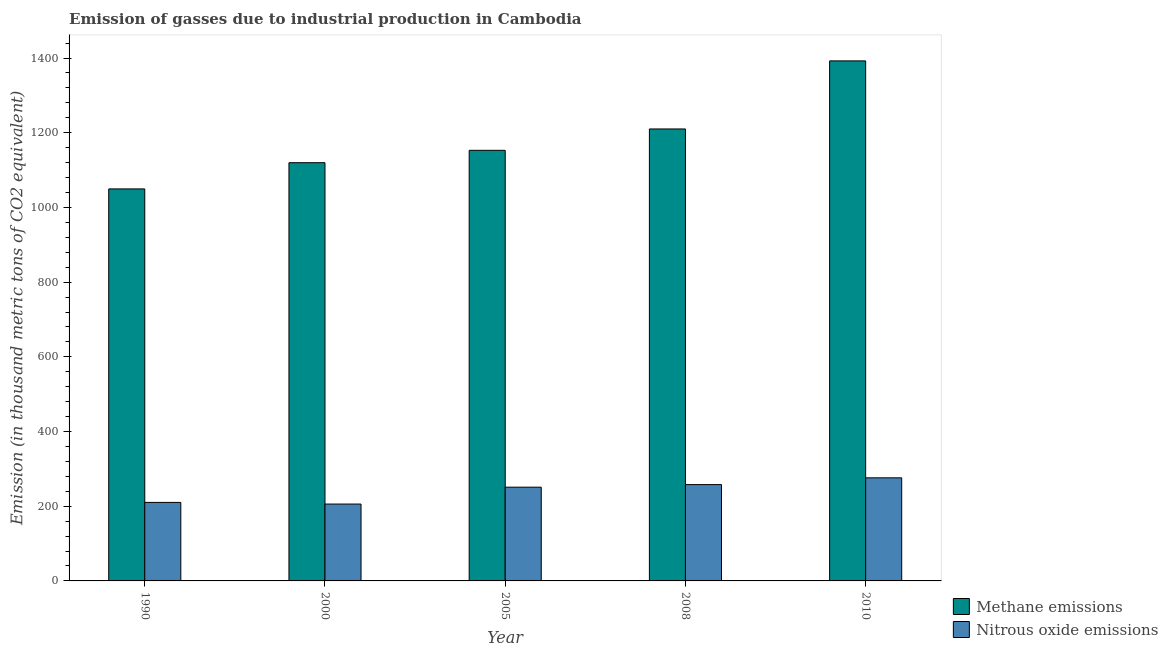Are the number of bars per tick equal to the number of legend labels?
Your response must be concise. Yes. How many bars are there on the 4th tick from the right?
Keep it short and to the point. 2. What is the amount of nitrous oxide emissions in 1990?
Give a very brief answer. 210.2. Across all years, what is the maximum amount of nitrous oxide emissions?
Provide a short and direct response. 276. Across all years, what is the minimum amount of nitrous oxide emissions?
Your answer should be very brief. 205.8. In which year was the amount of nitrous oxide emissions maximum?
Your answer should be compact. 2010. What is the total amount of nitrous oxide emissions in the graph?
Provide a short and direct response. 1200.9. What is the difference between the amount of nitrous oxide emissions in 2005 and that in 2010?
Your response must be concise. -25. What is the difference between the amount of methane emissions in 2000 and the amount of nitrous oxide emissions in 2008?
Offer a terse response. -90.3. What is the average amount of nitrous oxide emissions per year?
Offer a terse response. 240.18. What is the ratio of the amount of nitrous oxide emissions in 1990 to that in 2010?
Your answer should be compact. 0.76. What is the difference between the highest and the second highest amount of methane emissions?
Provide a succinct answer. 182.3. What is the difference between the highest and the lowest amount of methane emissions?
Provide a succinct answer. 342.8. Is the sum of the amount of nitrous oxide emissions in 2005 and 2010 greater than the maximum amount of methane emissions across all years?
Ensure brevity in your answer.  Yes. What does the 2nd bar from the left in 2010 represents?
Your response must be concise. Nitrous oxide emissions. What does the 1st bar from the right in 2005 represents?
Offer a very short reply. Nitrous oxide emissions. How many bars are there?
Your response must be concise. 10. Are all the bars in the graph horizontal?
Your answer should be compact. No. How many years are there in the graph?
Ensure brevity in your answer.  5. What is the difference between two consecutive major ticks on the Y-axis?
Make the answer very short. 200. Does the graph contain any zero values?
Provide a short and direct response. No. How many legend labels are there?
Your response must be concise. 2. What is the title of the graph?
Give a very brief answer. Emission of gasses due to industrial production in Cambodia. What is the label or title of the Y-axis?
Your answer should be compact. Emission (in thousand metric tons of CO2 equivalent). What is the Emission (in thousand metric tons of CO2 equivalent) of Methane emissions in 1990?
Your response must be concise. 1049.6. What is the Emission (in thousand metric tons of CO2 equivalent) of Nitrous oxide emissions in 1990?
Your response must be concise. 210.2. What is the Emission (in thousand metric tons of CO2 equivalent) of Methane emissions in 2000?
Make the answer very short. 1119.8. What is the Emission (in thousand metric tons of CO2 equivalent) in Nitrous oxide emissions in 2000?
Make the answer very short. 205.8. What is the Emission (in thousand metric tons of CO2 equivalent) of Methane emissions in 2005?
Offer a terse response. 1152.9. What is the Emission (in thousand metric tons of CO2 equivalent) in Nitrous oxide emissions in 2005?
Your response must be concise. 251. What is the Emission (in thousand metric tons of CO2 equivalent) of Methane emissions in 2008?
Offer a terse response. 1210.1. What is the Emission (in thousand metric tons of CO2 equivalent) of Nitrous oxide emissions in 2008?
Your response must be concise. 257.9. What is the Emission (in thousand metric tons of CO2 equivalent) in Methane emissions in 2010?
Ensure brevity in your answer.  1392.4. What is the Emission (in thousand metric tons of CO2 equivalent) of Nitrous oxide emissions in 2010?
Your answer should be compact. 276. Across all years, what is the maximum Emission (in thousand metric tons of CO2 equivalent) of Methane emissions?
Your answer should be compact. 1392.4. Across all years, what is the maximum Emission (in thousand metric tons of CO2 equivalent) in Nitrous oxide emissions?
Provide a short and direct response. 276. Across all years, what is the minimum Emission (in thousand metric tons of CO2 equivalent) in Methane emissions?
Ensure brevity in your answer.  1049.6. Across all years, what is the minimum Emission (in thousand metric tons of CO2 equivalent) in Nitrous oxide emissions?
Your answer should be very brief. 205.8. What is the total Emission (in thousand metric tons of CO2 equivalent) of Methane emissions in the graph?
Provide a short and direct response. 5924.8. What is the total Emission (in thousand metric tons of CO2 equivalent) of Nitrous oxide emissions in the graph?
Ensure brevity in your answer.  1200.9. What is the difference between the Emission (in thousand metric tons of CO2 equivalent) of Methane emissions in 1990 and that in 2000?
Provide a succinct answer. -70.2. What is the difference between the Emission (in thousand metric tons of CO2 equivalent) in Methane emissions in 1990 and that in 2005?
Your answer should be compact. -103.3. What is the difference between the Emission (in thousand metric tons of CO2 equivalent) of Nitrous oxide emissions in 1990 and that in 2005?
Offer a very short reply. -40.8. What is the difference between the Emission (in thousand metric tons of CO2 equivalent) in Methane emissions in 1990 and that in 2008?
Your answer should be compact. -160.5. What is the difference between the Emission (in thousand metric tons of CO2 equivalent) in Nitrous oxide emissions in 1990 and that in 2008?
Ensure brevity in your answer.  -47.7. What is the difference between the Emission (in thousand metric tons of CO2 equivalent) in Methane emissions in 1990 and that in 2010?
Provide a short and direct response. -342.8. What is the difference between the Emission (in thousand metric tons of CO2 equivalent) of Nitrous oxide emissions in 1990 and that in 2010?
Offer a terse response. -65.8. What is the difference between the Emission (in thousand metric tons of CO2 equivalent) of Methane emissions in 2000 and that in 2005?
Your answer should be very brief. -33.1. What is the difference between the Emission (in thousand metric tons of CO2 equivalent) of Nitrous oxide emissions in 2000 and that in 2005?
Ensure brevity in your answer.  -45.2. What is the difference between the Emission (in thousand metric tons of CO2 equivalent) of Methane emissions in 2000 and that in 2008?
Keep it short and to the point. -90.3. What is the difference between the Emission (in thousand metric tons of CO2 equivalent) in Nitrous oxide emissions in 2000 and that in 2008?
Make the answer very short. -52.1. What is the difference between the Emission (in thousand metric tons of CO2 equivalent) in Methane emissions in 2000 and that in 2010?
Your answer should be compact. -272.6. What is the difference between the Emission (in thousand metric tons of CO2 equivalent) in Nitrous oxide emissions in 2000 and that in 2010?
Your answer should be compact. -70.2. What is the difference between the Emission (in thousand metric tons of CO2 equivalent) of Methane emissions in 2005 and that in 2008?
Provide a short and direct response. -57.2. What is the difference between the Emission (in thousand metric tons of CO2 equivalent) in Methane emissions in 2005 and that in 2010?
Give a very brief answer. -239.5. What is the difference between the Emission (in thousand metric tons of CO2 equivalent) of Nitrous oxide emissions in 2005 and that in 2010?
Offer a terse response. -25. What is the difference between the Emission (in thousand metric tons of CO2 equivalent) of Methane emissions in 2008 and that in 2010?
Offer a very short reply. -182.3. What is the difference between the Emission (in thousand metric tons of CO2 equivalent) in Nitrous oxide emissions in 2008 and that in 2010?
Your answer should be compact. -18.1. What is the difference between the Emission (in thousand metric tons of CO2 equivalent) in Methane emissions in 1990 and the Emission (in thousand metric tons of CO2 equivalent) in Nitrous oxide emissions in 2000?
Your answer should be very brief. 843.8. What is the difference between the Emission (in thousand metric tons of CO2 equivalent) in Methane emissions in 1990 and the Emission (in thousand metric tons of CO2 equivalent) in Nitrous oxide emissions in 2005?
Ensure brevity in your answer.  798.6. What is the difference between the Emission (in thousand metric tons of CO2 equivalent) in Methane emissions in 1990 and the Emission (in thousand metric tons of CO2 equivalent) in Nitrous oxide emissions in 2008?
Keep it short and to the point. 791.7. What is the difference between the Emission (in thousand metric tons of CO2 equivalent) in Methane emissions in 1990 and the Emission (in thousand metric tons of CO2 equivalent) in Nitrous oxide emissions in 2010?
Your answer should be compact. 773.6. What is the difference between the Emission (in thousand metric tons of CO2 equivalent) in Methane emissions in 2000 and the Emission (in thousand metric tons of CO2 equivalent) in Nitrous oxide emissions in 2005?
Make the answer very short. 868.8. What is the difference between the Emission (in thousand metric tons of CO2 equivalent) of Methane emissions in 2000 and the Emission (in thousand metric tons of CO2 equivalent) of Nitrous oxide emissions in 2008?
Your answer should be very brief. 861.9. What is the difference between the Emission (in thousand metric tons of CO2 equivalent) of Methane emissions in 2000 and the Emission (in thousand metric tons of CO2 equivalent) of Nitrous oxide emissions in 2010?
Your answer should be compact. 843.8. What is the difference between the Emission (in thousand metric tons of CO2 equivalent) of Methane emissions in 2005 and the Emission (in thousand metric tons of CO2 equivalent) of Nitrous oxide emissions in 2008?
Offer a very short reply. 895. What is the difference between the Emission (in thousand metric tons of CO2 equivalent) in Methane emissions in 2005 and the Emission (in thousand metric tons of CO2 equivalent) in Nitrous oxide emissions in 2010?
Your answer should be very brief. 876.9. What is the difference between the Emission (in thousand metric tons of CO2 equivalent) of Methane emissions in 2008 and the Emission (in thousand metric tons of CO2 equivalent) of Nitrous oxide emissions in 2010?
Your answer should be compact. 934.1. What is the average Emission (in thousand metric tons of CO2 equivalent) in Methane emissions per year?
Your answer should be very brief. 1184.96. What is the average Emission (in thousand metric tons of CO2 equivalent) in Nitrous oxide emissions per year?
Ensure brevity in your answer.  240.18. In the year 1990, what is the difference between the Emission (in thousand metric tons of CO2 equivalent) of Methane emissions and Emission (in thousand metric tons of CO2 equivalent) of Nitrous oxide emissions?
Your response must be concise. 839.4. In the year 2000, what is the difference between the Emission (in thousand metric tons of CO2 equivalent) of Methane emissions and Emission (in thousand metric tons of CO2 equivalent) of Nitrous oxide emissions?
Your answer should be very brief. 914. In the year 2005, what is the difference between the Emission (in thousand metric tons of CO2 equivalent) of Methane emissions and Emission (in thousand metric tons of CO2 equivalent) of Nitrous oxide emissions?
Your answer should be compact. 901.9. In the year 2008, what is the difference between the Emission (in thousand metric tons of CO2 equivalent) in Methane emissions and Emission (in thousand metric tons of CO2 equivalent) in Nitrous oxide emissions?
Ensure brevity in your answer.  952.2. In the year 2010, what is the difference between the Emission (in thousand metric tons of CO2 equivalent) of Methane emissions and Emission (in thousand metric tons of CO2 equivalent) of Nitrous oxide emissions?
Keep it short and to the point. 1116.4. What is the ratio of the Emission (in thousand metric tons of CO2 equivalent) of Methane emissions in 1990 to that in 2000?
Offer a terse response. 0.94. What is the ratio of the Emission (in thousand metric tons of CO2 equivalent) of Nitrous oxide emissions in 1990 to that in 2000?
Ensure brevity in your answer.  1.02. What is the ratio of the Emission (in thousand metric tons of CO2 equivalent) in Methane emissions in 1990 to that in 2005?
Your answer should be compact. 0.91. What is the ratio of the Emission (in thousand metric tons of CO2 equivalent) of Nitrous oxide emissions in 1990 to that in 2005?
Make the answer very short. 0.84. What is the ratio of the Emission (in thousand metric tons of CO2 equivalent) in Methane emissions in 1990 to that in 2008?
Ensure brevity in your answer.  0.87. What is the ratio of the Emission (in thousand metric tons of CO2 equivalent) in Nitrous oxide emissions in 1990 to that in 2008?
Ensure brevity in your answer.  0.81. What is the ratio of the Emission (in thousand metric tons of CO2 equivalent) of Methane emissions in 1990 to that in 2010?
Your answer should be very brief. 0.75. What is the ratio of the Emission (in thousand metric tons of CO2 equivalent) of Nitrous oxide emissions in 1990 to that in 2010?
Offer a very short reply. 0.76. What is the ratio of the Emission (in thousand metric tons of CO2 equivalent) of Methane emissions in 2000 to that in 2005?
Provide a succinct answer. 0.97. What is the ratio of the Emission (in thousand metric tons of CO2 equivalent) of Nitrous oxide emissions in 2000 to that in 2005?
Ensure brevity in your answer.  0.82. What is the ratio of the Emission (in thousand metric tons of CO2 equivalent) in Methane emissions in 2000 to that in 2008?
Offer a terse response. 0.93. What is the ratio of the Emission (in thousand metric tons of CO2 equivalent) of Nitrous oxide emissions in 2000 to that in 2008?
Your answer should be very brief. 0.8. What is the ratio of the Emission (in thousand metric tons of CO2 equivalent) in Methane emissions in 2000 to that in 2010?
Ensure brevity in your answer.  0.8. What is the ratio of the Emission (in thousand metric tons of CO2 equivalent) of Nitrous oxide emissions in 2000 to that in 2010?
Ensure brevity in your answer.  0.75. What is the ratio of the Emission (in thousand metric tons of CO2 equivalent) of Methane emissions in 2005 to that in 2008?
Give a very brief answer. 0.95. What is the ratio of the Emission (in thousand metric tons of CO2 equivalent) of Nitrous oxide emissions in 2005 to that in 2008?
Your answer should be compact. 0.97. What is the ratio of the Emission (in thousand metric tons of CO2 equivalent) of Methane emissions in 2005 to that in 2010?
Keep it short and to the point. 0.83. What is the ratio of the Emission (in thousand metric tons of CO2 equivalent) in Nitrous oxide emissions in 2005 to that in 2010?
Your response must be concise. 0.91. What is the ratio of the Emission (in thousand metric tons of CO2 equivalent) of Methane emissions in 2008 to that in 2010?
Offer a very short reply. 0.87. What is the ratio of the Emission (in thousand metric tons of CO2 equivalent) in Nitrous oxide emissions in 2008 to that in 2010?
Your answer should be compact. 0.93. What is the difference between the highest and the second highest Emission (in thousand metric tons of CO2 equivalent) of Methane emissions?
Your response must be concise. 182.3. What is the difference between the highest and the lowest Emission (in thousand metric tons of CO2 equivalent) of Methane emissions?
Keep it short and to the point. 342.8. What is the difference between the highest and the lowest Emission (in thousand metric tons of CO2 equivalent) in Nitrous oxide emissions?
Give a very brief answer. 70.2. 